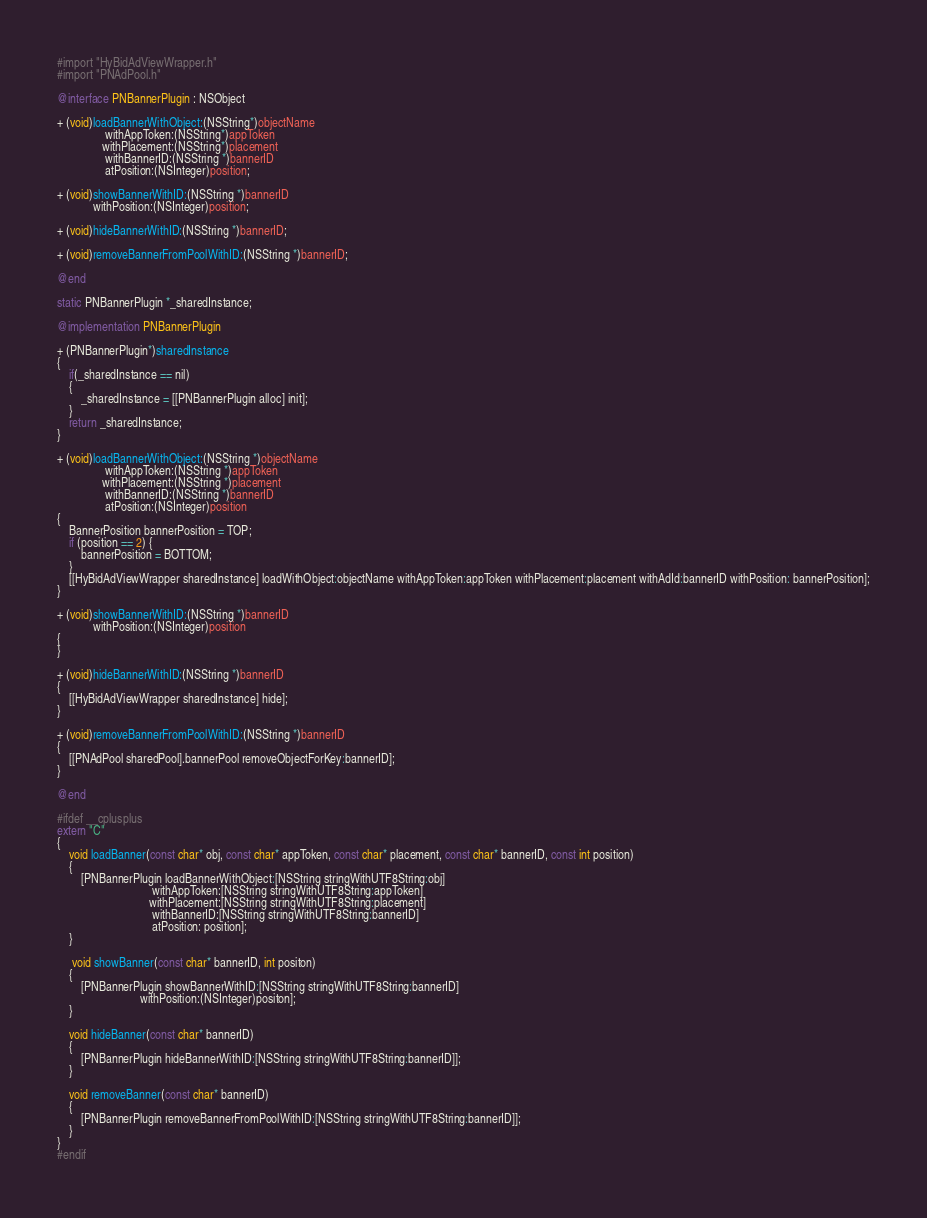Convert code to text. <code><loc_0><loc_0><loc_500><loc_500><_ObjectiveC_>#import "HyBidAdViewWrapper.h"
#import "PNAdPool.h"

@interface PNBannerPlugin : NSObject

+ (void)loadBannerWithObject:(NSString*)objectName
                withAppToken:(NSString*)appToken
               withPlacement:(NSString*)placement
                withBannerID:(NSString *)bannerID
                atPosition:(NSInteger)position;

+ (void)showBannerWithID:(NSString *)bannerID
            withPosition:(NSInteger)position;

+ (void)hideBannerWithID:(NSString *)bannerID;

+ (void)removeBannerFromPoolWithID:(NSString *)bannerID;

@end

static PNBannerPlugin *_sharedInstance;

@implementation PNBannerPlugin

+ (PNBannerPlugin*)sharedInstance
{
    if(_sharedInstance == nil)
    {
        _sharedInstance = [[PNBannerPlugin alloc] init];
    }
    return _sharedInstance;
}

+ (void)loadBannerWithObject:(NSString *)objectName
                withAppToken:(NSString *)appToken
               withPlacement:(NSString *)placement
                withBannerID:(NSString *)bannerID
                atPosition:(NSInteger)position
{
    BannerPosition bannerPosition = TOP;
    if (position == 2) {
        bannerPosition = BOTTOM;
    }
    [[HyBidAdViewWrapper sharedInstance] loadWithObject:objectName withAppToken:appToken withPlacement:placement withAdId:bannerID withPosition: bannerPosition];
}

+ (void)showBannerWithID:(NSString *)bannerID
            withPosition:(NSInteger)position
{
}

+ (void)hideBannerWithID:(NSString *)bannerID
{
    [[HyBidAdViewWrapper sharedInstance] hide];
}

+ (void)removeBannerFromPoolWithID:(NSString *)bannerID
{
    [[PNAdPool sharedPool].bannerPool removeObjectForKey:bannerID];
}

@end

#ifdef __cplusplus
extern "C"
{
    void loadBanner(const char* obj, const char* appToken, const char* placement, const char* bannerID, const int position)
    {
        [PNBannerPlugin loadBannerWithObject:[NSString stringWithUTF8String:obj]
                                withAppToken:[NSString stringWithUTF8String:appToken]
                               withPlacement:[NSString stringWithUTF8String:placement]
                                withBannerID:[NSString stringWithUTF8String:bannerID]
                                atPosition: position];
    }
    
     void showBanner(const char* bannerID, int positon)
    {
        [PNBannerPlugin showBannerWithID:[NSString stringWithUTF8String:bannerID]
                            withPosition:(NSInteger)positon];
    }
    
    void hideBanner(const char* bannerID)
    {
        [PNBannerPlugin hideBannerWithID:[NSString stringWithUTF8String:bannerID]];
    }
    
    void removeBanner(const char* bannerID)
    {
        [PNBannerPlugin removeBannerFromPoolWithID:[NSString stringWithUTF8String:bannerID]];
    }
}
#endif
</code> 